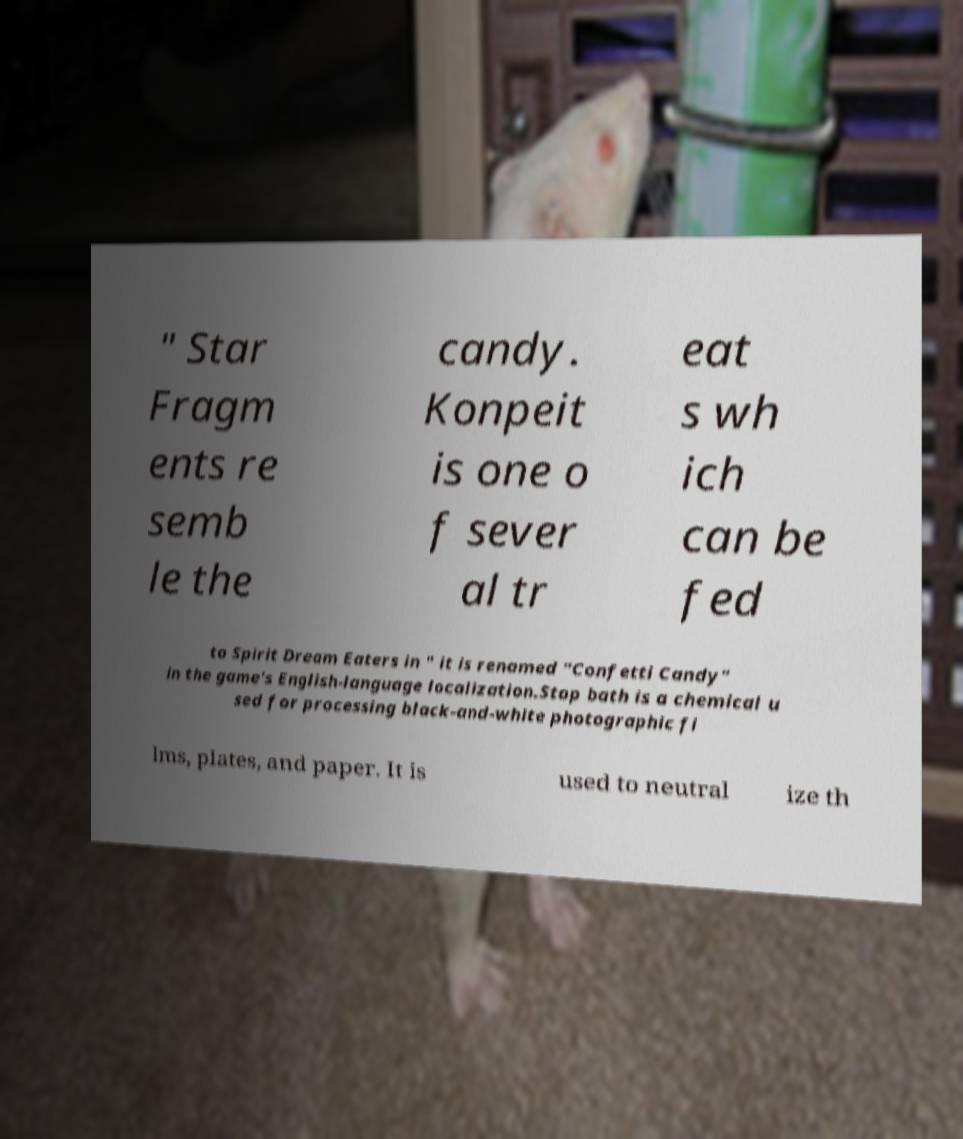Please identify and transcribe the text found in this image. " Star Fragm ents re semb le the candy. Konpeit is one o f sever al tr eat s wh ich can be fed to Spirit Dream Eaters in " it is renamed "Confetti Candy" in the game's English-language localization.Stop bath is a chemical u sed for processing black-and-white photographic fi lms, plates, and paper. It is used to neutral ize th 